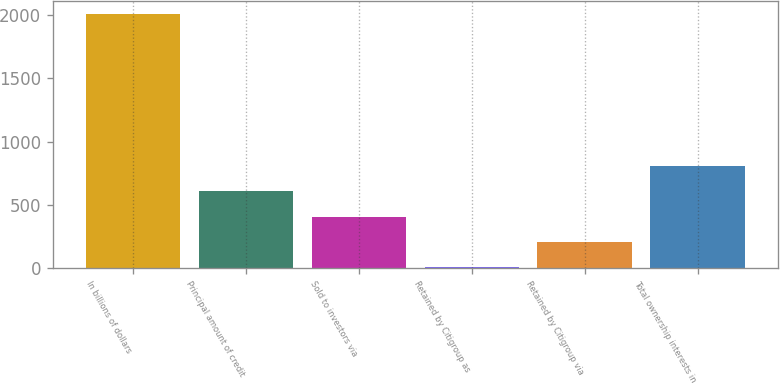Convert chart. <chart><loc_0><loc_0><loc_500><loc_500><bar_chart><fcel>In billions of dollars<fcel>Principal amount of credit<fcel>Sold to investors via<fcel>Retained by Citigroup as<fcel>Retained by Citigroup via<fcel>Total ownership interests in<nl><fcel>2009<fcel>606.2<fcel>405.8<fcel>5<fcel>205.4<fcel>806.6<nl></chart> 